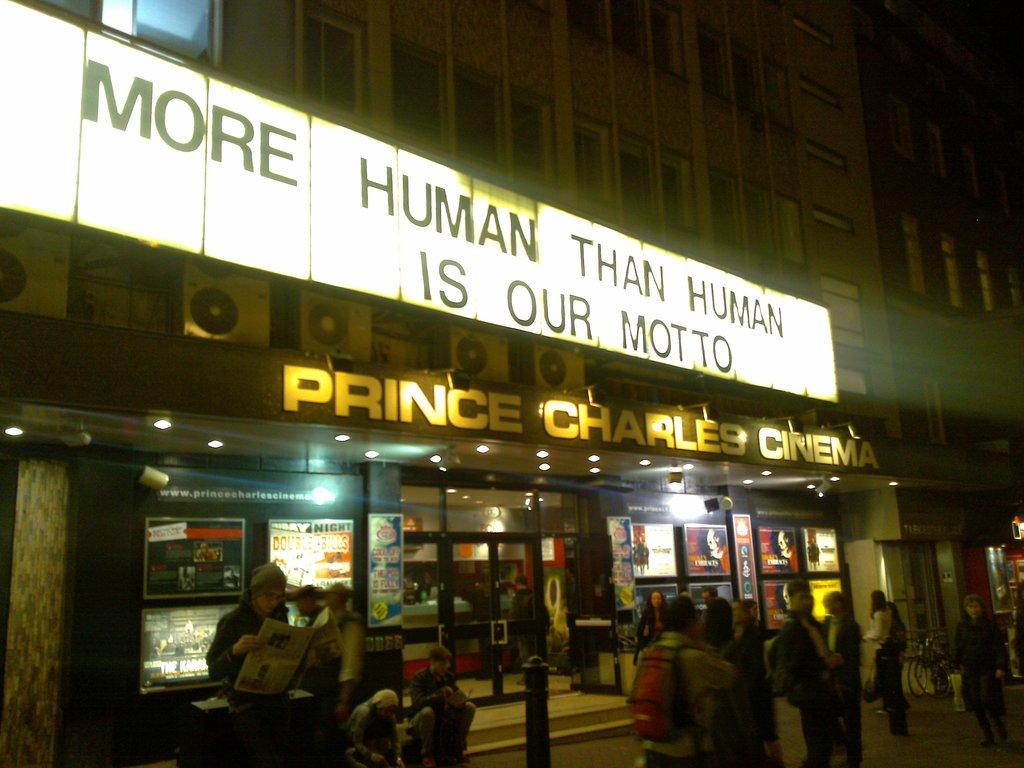What is their motto?
Your answer should be compact. More human than human. What is the name of this place?
Make the answer very short. Prince charles cinema. 